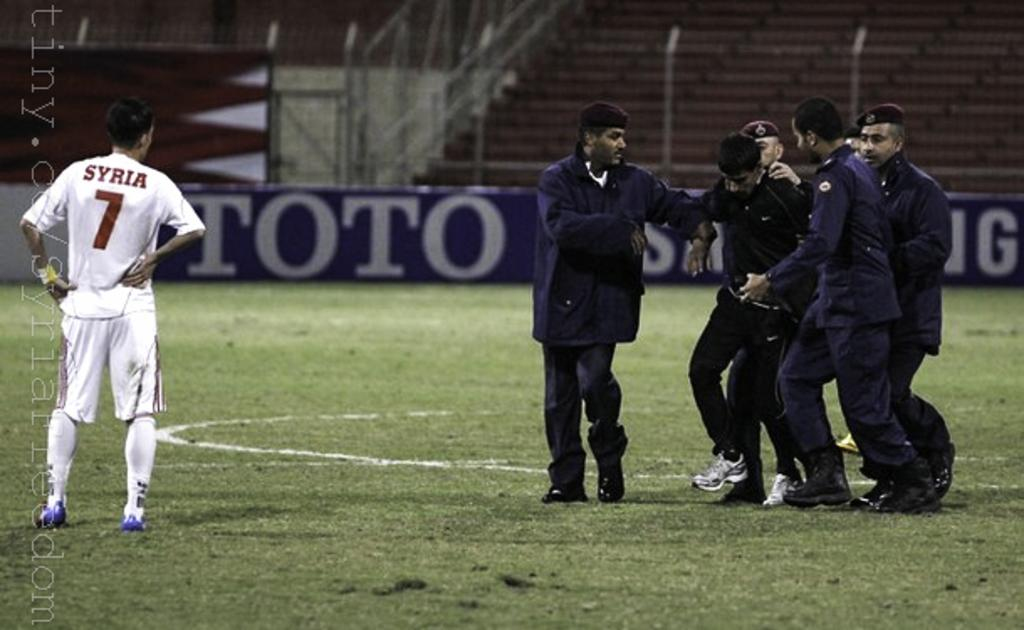<image>
Present a compact description of the photo's key features. A soccer player with the number 7 on his shirt 